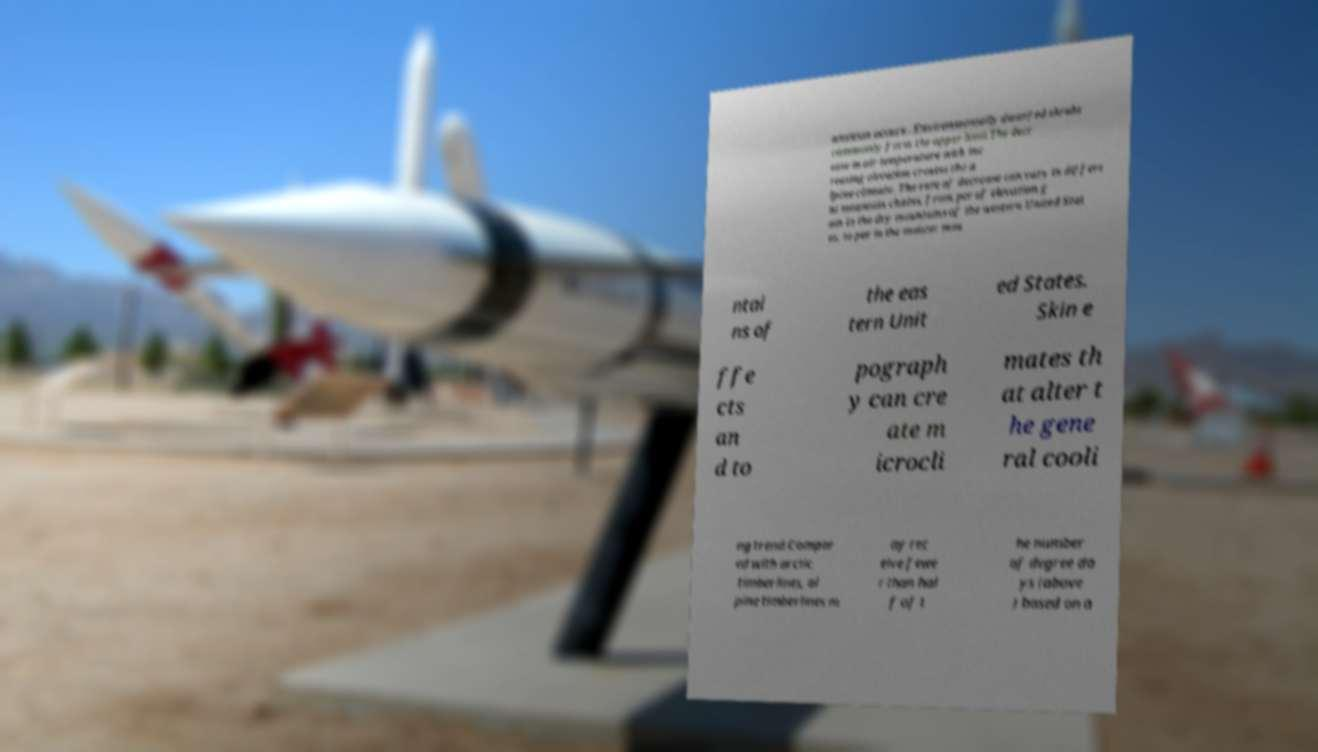There's text embedded in this image that I need extracted. Can you transcribe it verbatim? ansition occurs . Environmentally dwarfed shrubs commonly form the upper limit.The decr ease in air temperature with inc reasing elevation creates the a lpine climate. The rate of decrease can vary in differe nt mountain chains, from per of elevation g ain in the dry mountains of the western United Stat es, to per in the moister mou ntai ns of the eas tern Unit ed States. Skin e ffe cts an d to pograph y can cre ate m icrocli mates th at alter t he gene ral cooli ng trend.Compar ed with arctic timberlines, al pine timberlines m ay rec eive fewe r than hal f of t he number of degree da ys (above ) based on a 